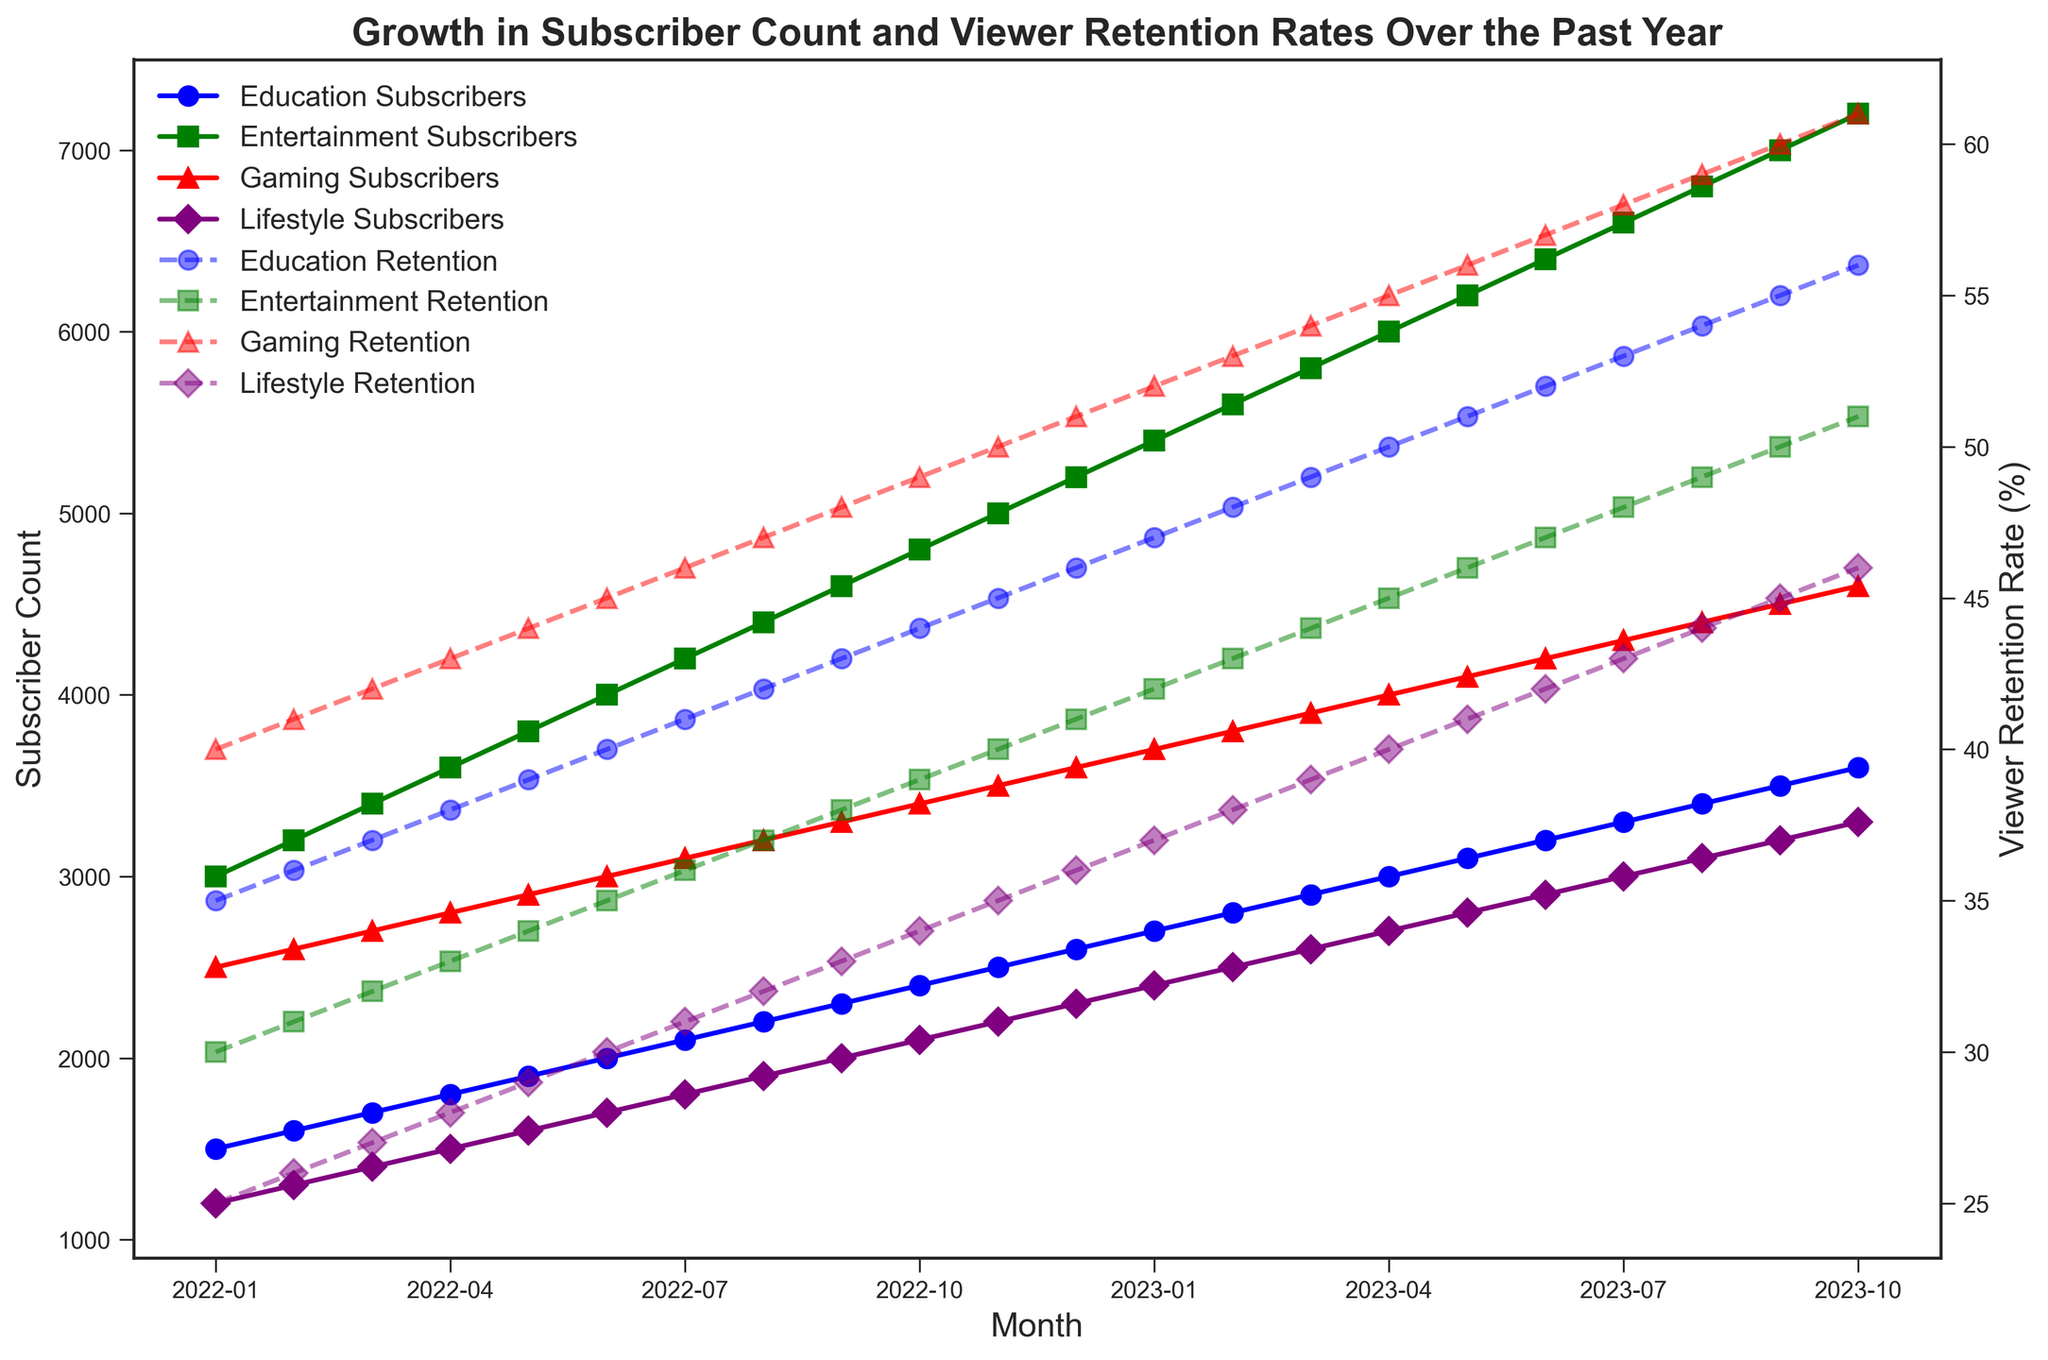What genre had the highest subscriber count in October 2023? To find the genre with the highest subscriber count, we look at the lines representing subscriber count and identify the one that peaks the highest in October 2023. We see the Entertainment line reaching the highest value.
Answer: Entertainment Which month did the Lifestyle genre see the highest viewer retention rate? For the Lifestyle genre, we track its dashed line for viewer retention rates across the months. We find the peak at October 2023.
Answer: October 2023 What is the approximate difference in subscriber count between the Entertainment and Gaming genres in June 2023? We locate June 2023 on the x-axis and compare the heights of the lines for both genres. The Entertainment genre has about 6400 subscribers, and the Gaming genre has about 4200 subscribers. The difference is 6400 - 4200 = 2200.
Answer: 2200 Across the entire timeline, which genre showed a consistent increase in both subscriber count and viewer retention rate? By examining the trajectories of both solid and dashed lines for each genre, we find that all genres show a consistent upward trend in both metrics from start to end.
Answer: All genres How does the viewer retention rate for Education in December 2022 compare to that in December 2021? December 2021 is not part of the data, so the comparison would be with January 2022. In January 2022, the Education genre has a retention rate of 35%. In December 2022, it has increased to 46%.
Answer: Increased Which genre had the greatest percentage increase in subscriber count from January 2022 to October 2023? Comparing the starting and ending points on the solid lines, we calculate the increase from January 2022 to October 2023. For example, Education went from 1500 to 3600 (increase of 2100), Entertainment from 3000 to 7200 (increase of 4200), Gaming from 2500 to 4600 (increase of 2100), and Lifestyle from 1200 to 3300 (increase of 2100). The greatest percentage increase is for Entertainment.
Answer: Entertainment Do subscriber counts for any genres intersect at any point over the year? By visually inspecting the solid lines, we check if any lines cross each other. No intersections are found among the solid lines for subscriber count for different genres.
Answer: No What is the total increase in viewer retention rate for the Gaming genre from January 2022 to October 2023? The Gaming viewer retention rate starts at 40% in January 2022 and increases to 61% in October 2023. The total increase is 61% - 40% = 21%.
Answer: 21% Does the viewer retention rate increase at the same rate for the Education and Lifestyle genres? By comparing the slopes of the dashed lines for both genres from January 2022 to October 2023, we see that both lines incline, though at potentially different rates. A precise calculation needs inspecting the rate of increase over each month. Both steadily increase but at slightly different rates.
Answer: No What is the average subscriber count for the Education genre from January 2022 to October 2023? Summing the Education subscriber counts for each month from January 2022 to October 2023 and dividing by the number of months (22), we find (1500+1600+...+3600)/22.
Answer: 2550 